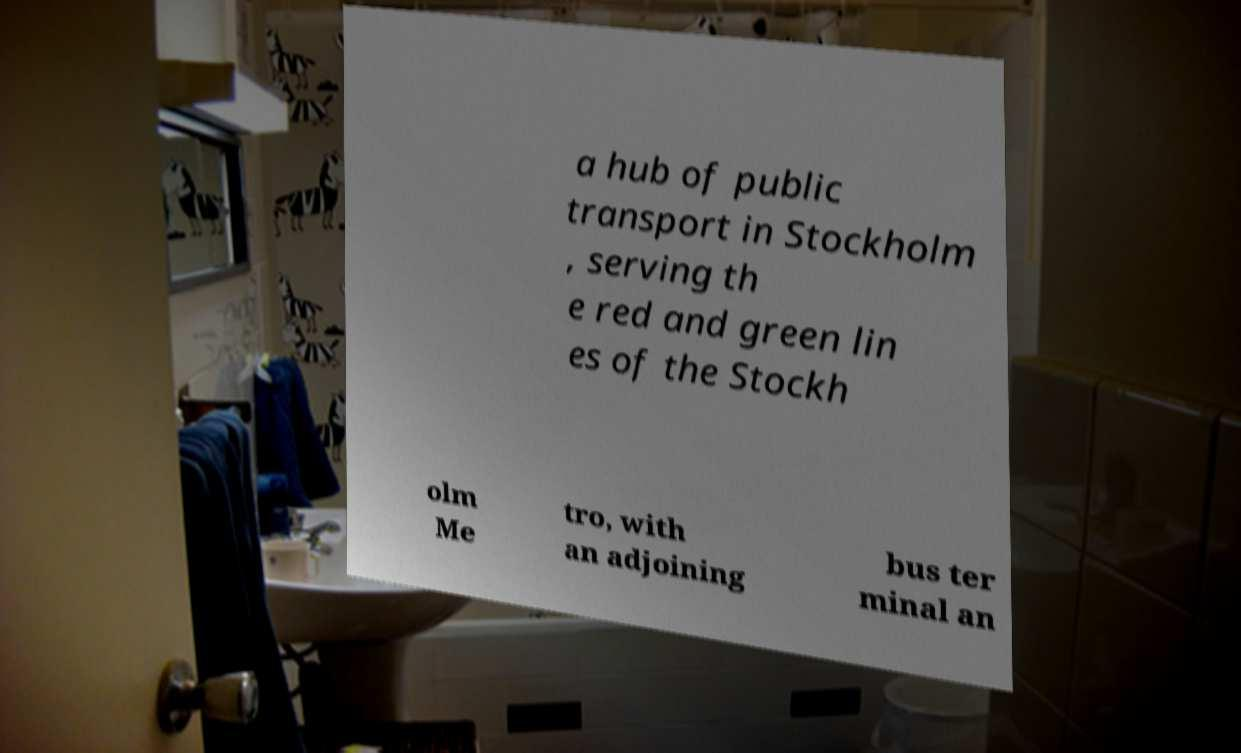There's text embedded in this image that I need extracted. Can you transcribe it verbatim? a hub of public transport in Stockholm , serving th e red and green lin es of the Stockh olm Me tro, with an adjoining bus ter minal an 